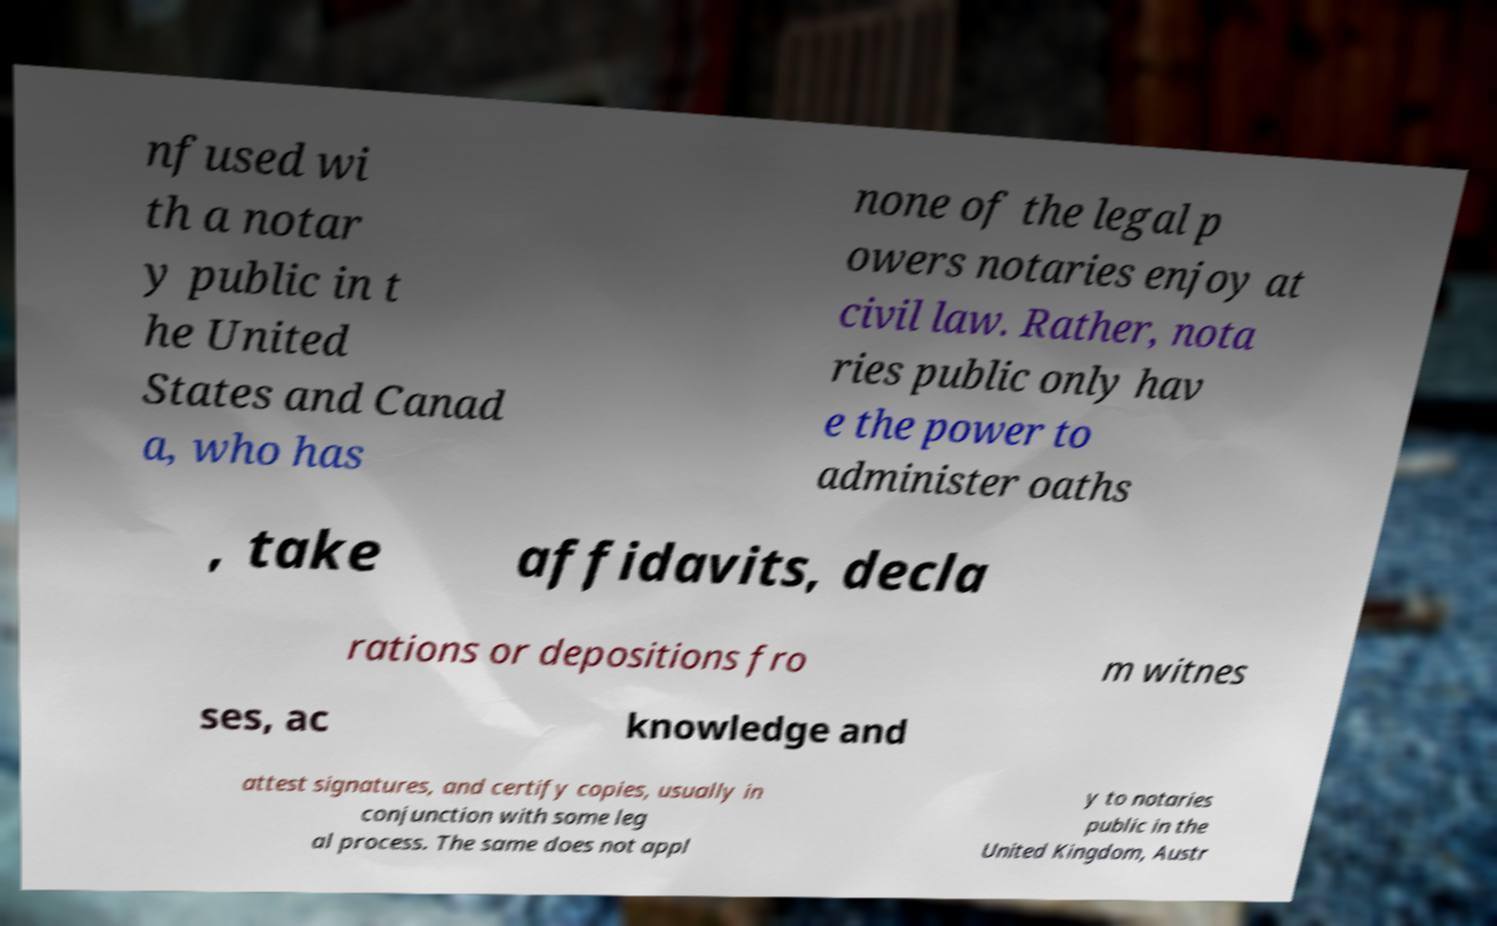Can you read and provide the text displayed in the image?This photo seems to have some interesting text. Can you extract and type it out for me? nfused wi th a notar y public in t he United States and Canad a, who has none of the legal p owers notaries enjoy at civil law. Rather, nota ries public only hav e the power to administer oaths , take affidavits, decla rations or depositions fro m witnes ses, ac knowledge and attest signatures, and certify copies, usually in conjunction with some leg al process. The same does not appl y to notaries public in the United Kingdom, Austr 